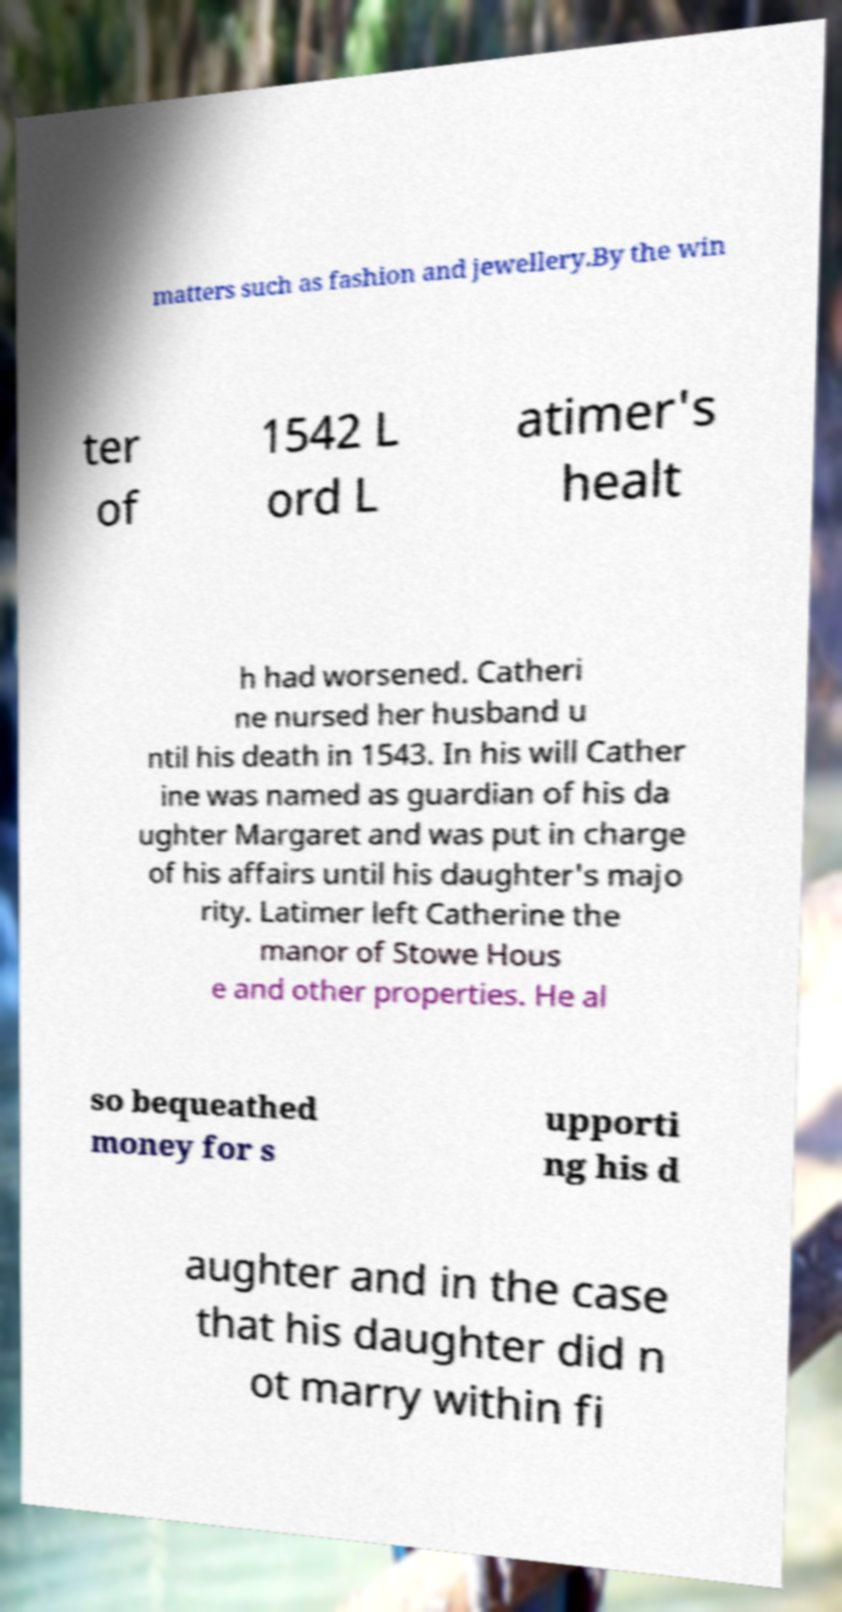There's text embedded in this image that I need extracted. Can you transcribe it verbatim? matters such as fashion and jewellery.By the win ter of 1542 L ord L atimer's healt h had worsened. Catheri ne nursed her husband u ntil his death in 1543. In his will Cather ine was named as guardian of his da ughter Margaret and was put in charge of his affairs until his daughter's majo rity. Latimer left Catherine the manor of Stowe Hous e and other properties. He al so bequeathed money for s upporti ng his d aughter and in the case that his daughter did n ot marry within fi 